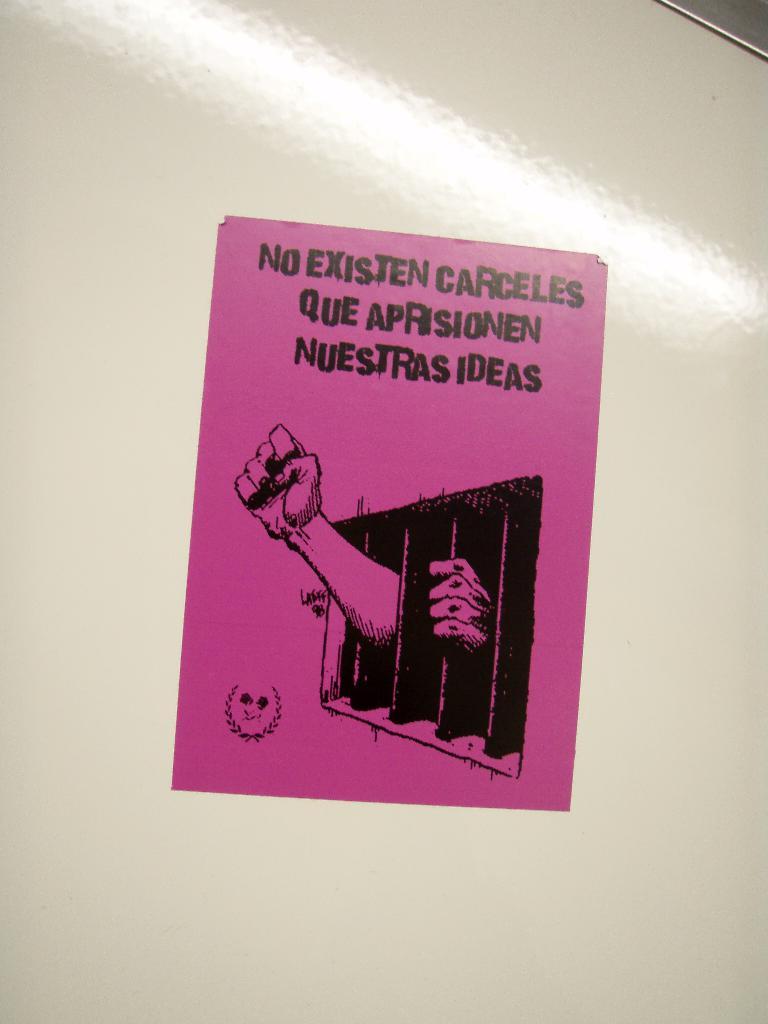What is this sign telling you?
Keep it short and to the point. No existen carceles que aprisionen nuestras ideas. 